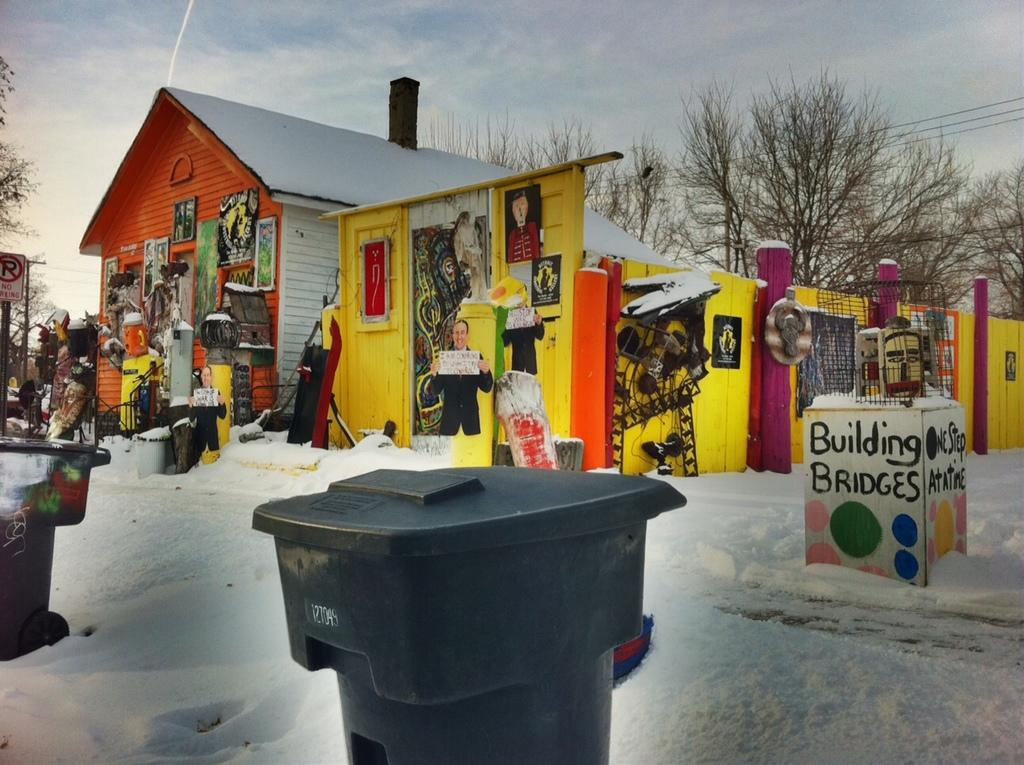<image>
Present a compact description of the photo's key features. House which has a sign that says "Building Bridges". 